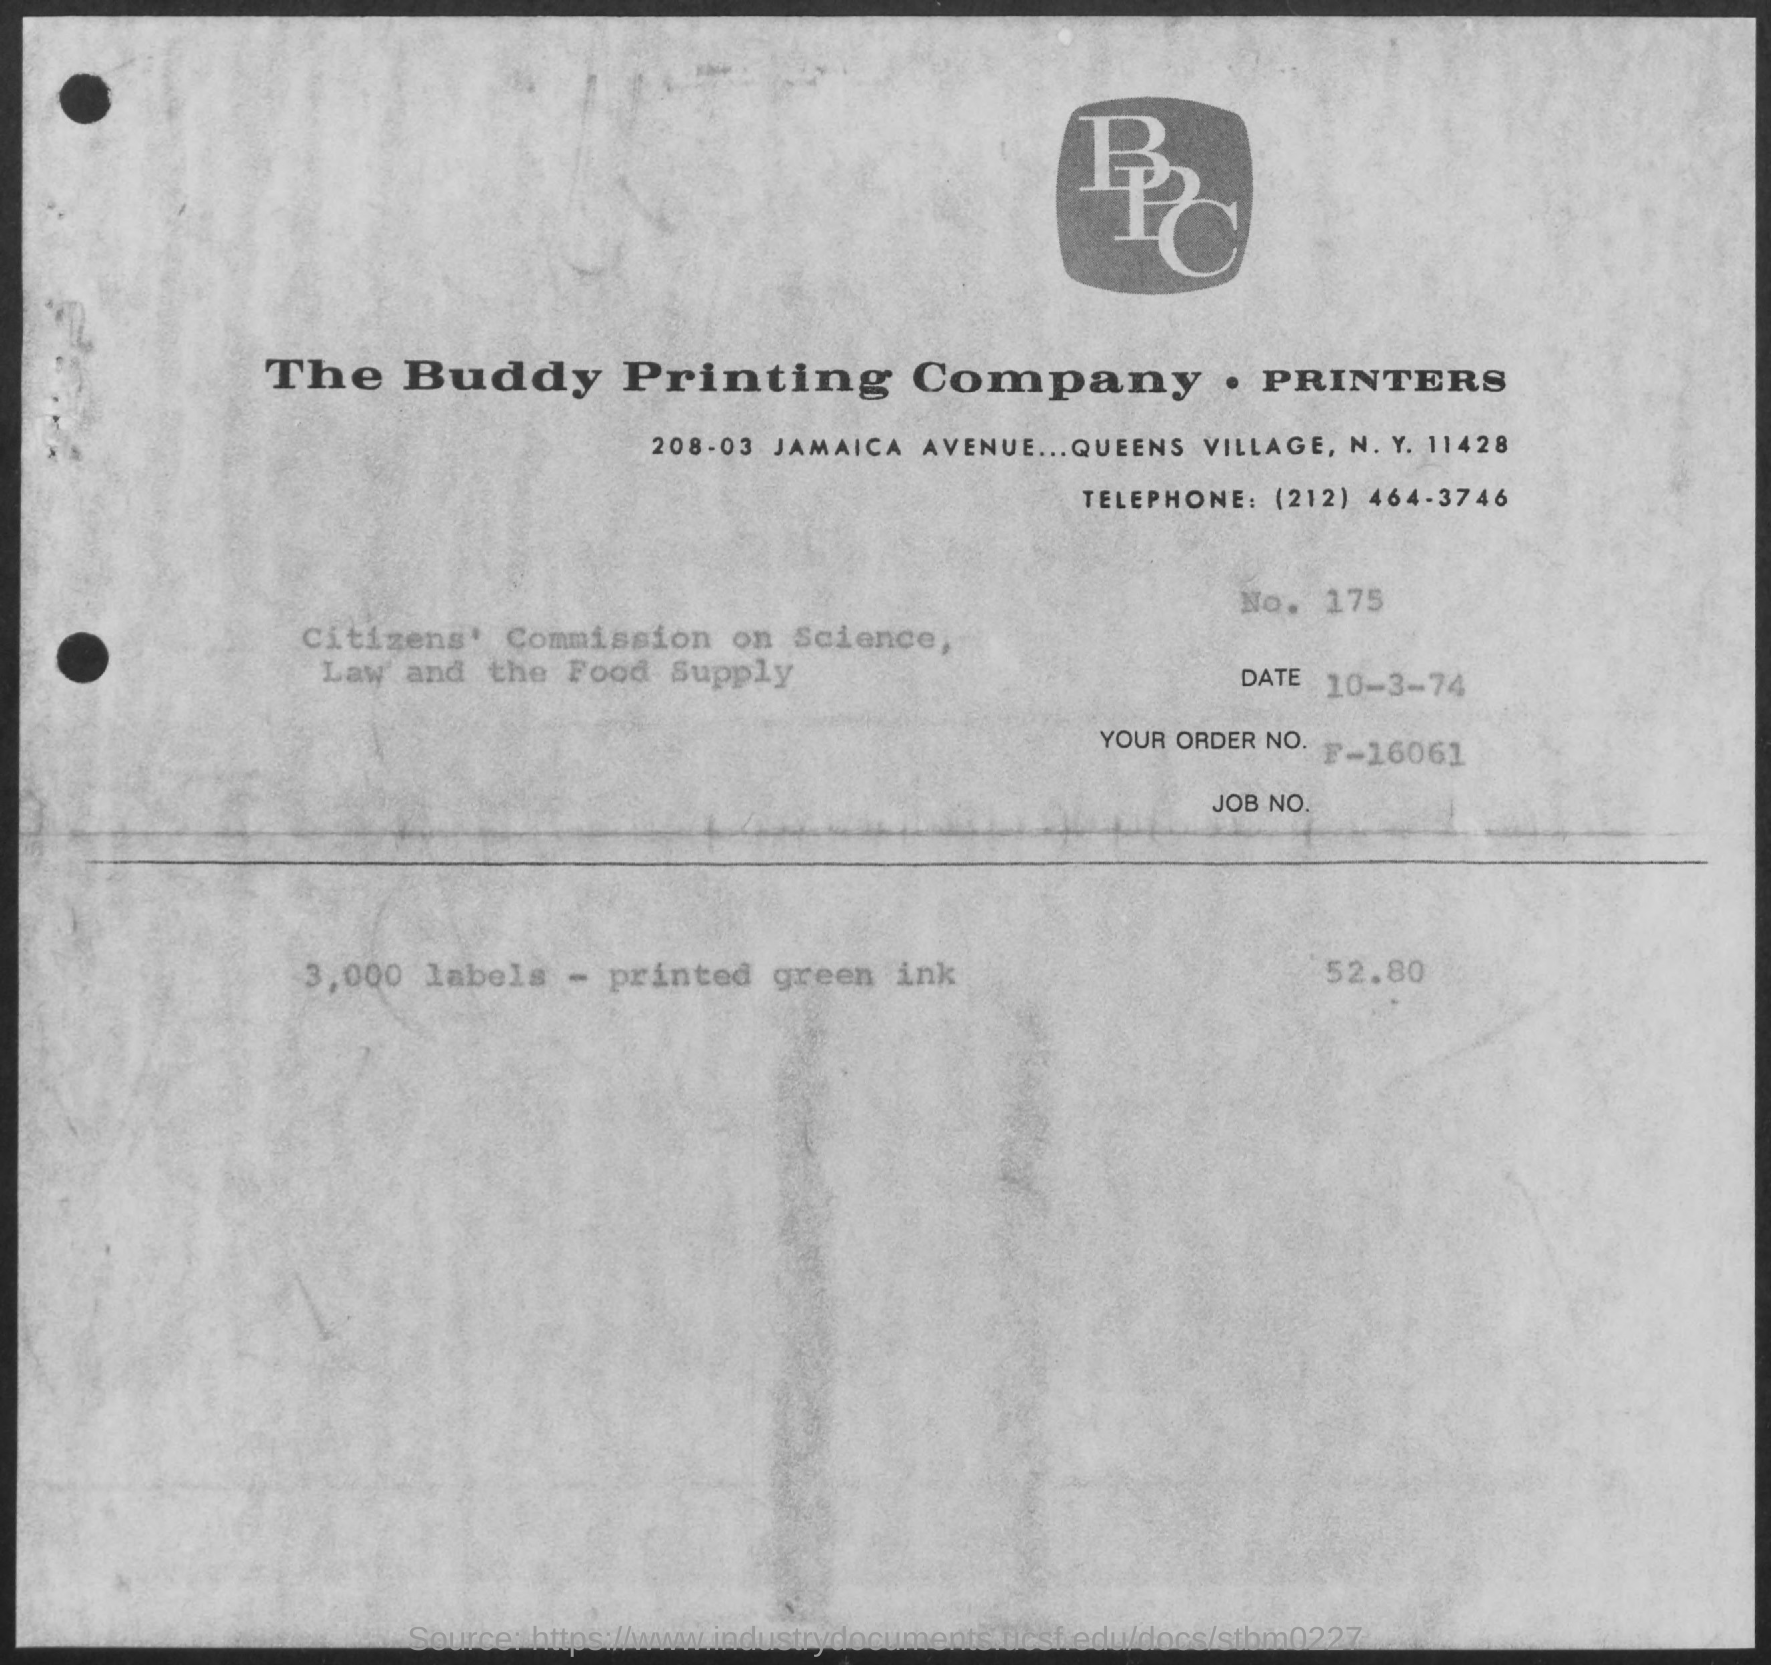What is the Date?
Your answer should be compact. 10-3-74. What is the order No.?
Provide a short and direct response. F-16061. 